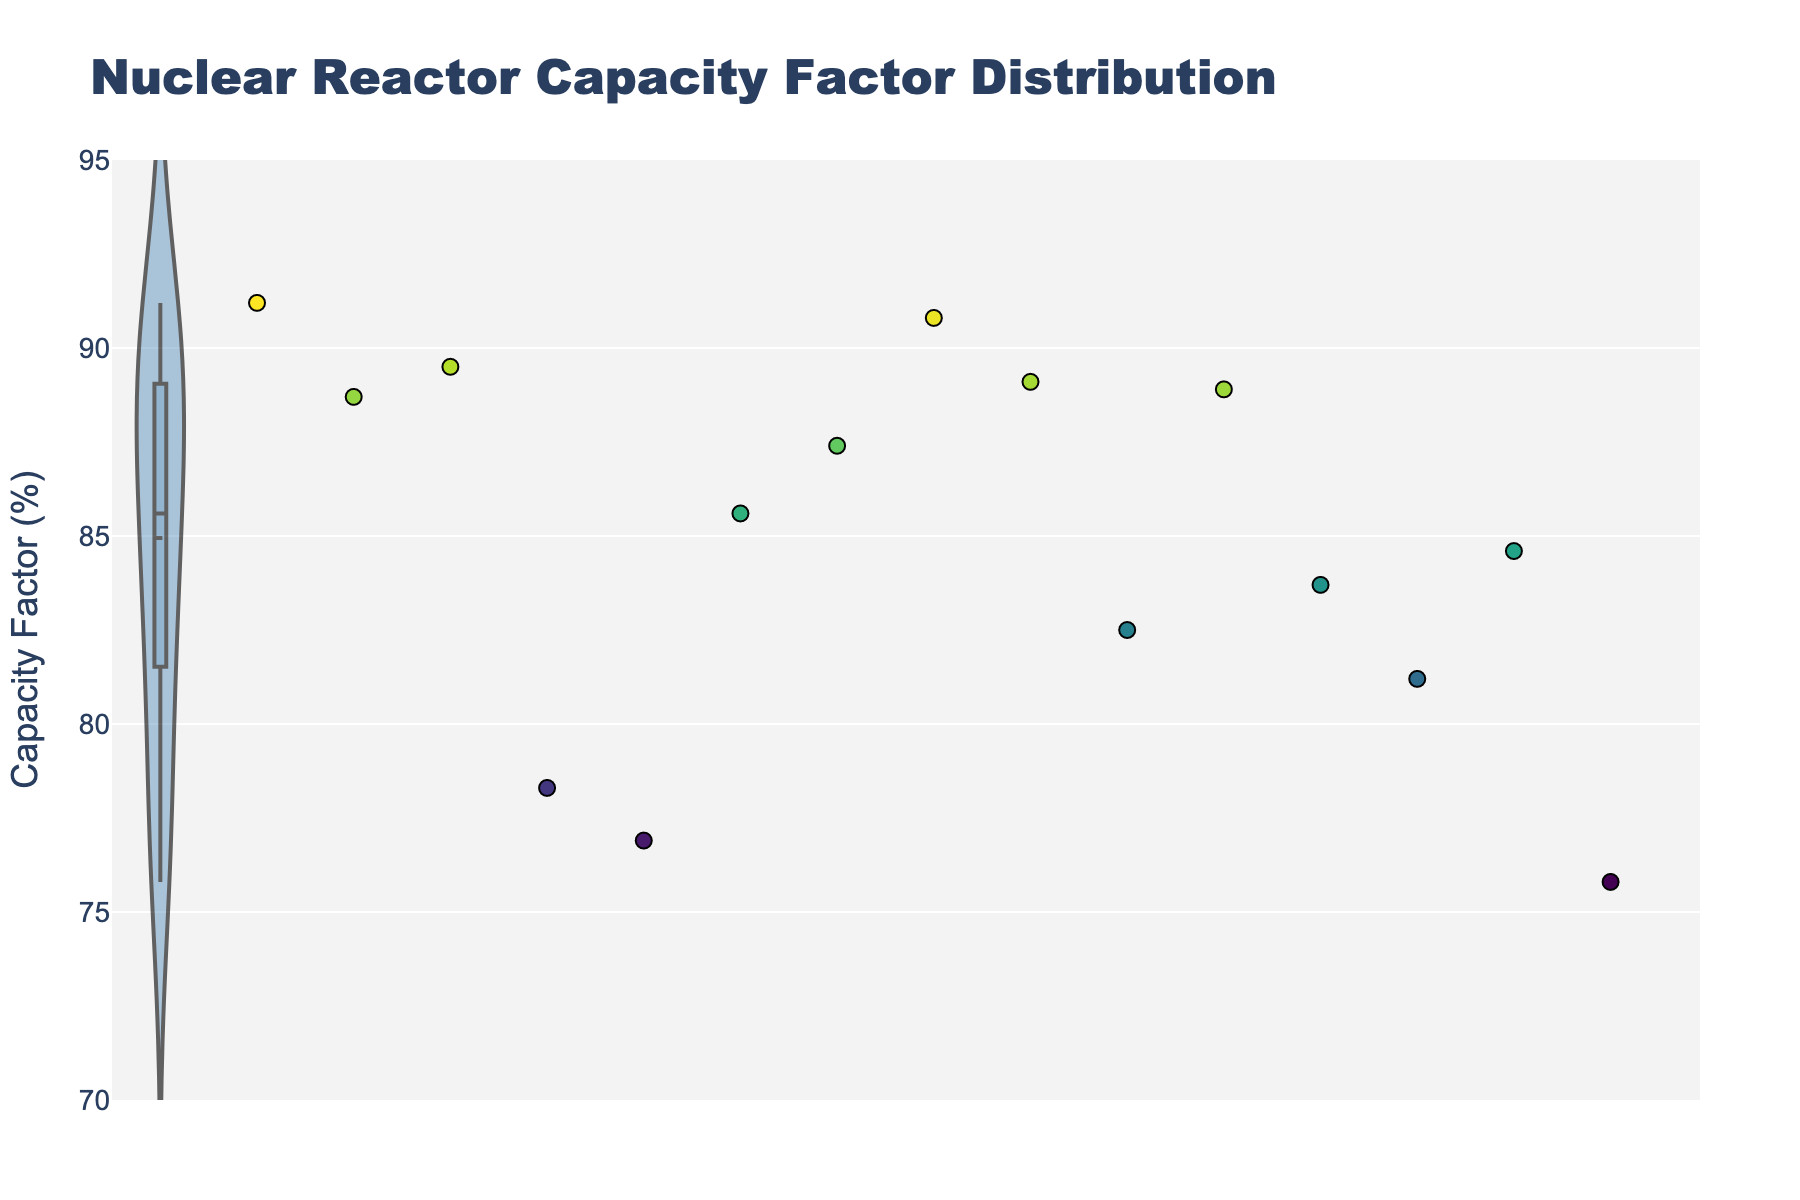What is the title of the plot? The title of the plot is displayed prominently at the top and clearly states the subject of the plot.
Answer: Nuclear Reactor Capacity Factor Distribution What is the range of the y-axis? The y-axis range can be determined by looking at the lowest and highest values marked on the y-axis.
Answer: 70 to 95 How many reactor types are represented in the plot? Each data point in the scatter plot represents a reactor type. Count the number of unique points.
Answer: 15 Which reactor type has the lowest capacity factor? Hover over the scatter points to see the capacity factors of each reactor type. Identify the one with the lowest value.
Answer: Magnox What is the average capacity factor of all reactor types? Sum up all the capacity factors and divide by the total number of reactor types. \(\frac{(91.2 + 88.7 + 89.5 + 78.3 + 76.9 + 85.6 + 87.4 + 90.8 + 89.1 + 82.5 + 88.9 + 83.7 + 81.2 + 84.6 + 75.8)}{15}\)
Answer: 84.7 What is the difference between the highest and lowest capacity factors? Identify the highest and lowest capacity factors on the plot and subtract the lowest from the highest (91.2 - 75.8).
Answer: 15.4 Which reactor type has a capacity factor closest to 90%? Hover over the scatter points to see the capacity factors. Identify the data point with a value close to 90%.
Answer: AP1000 How many reactor types have a capacity factor above 85%? Count the scatter points that have capacity factors greater than 85 by hovering over each of them.
Answer: 8 What's the capacity factor of Pressurized Water Reactor compared to Boiling Water Reactor? Look at the capacity factor values for both reactor types and compare them (91.2 for Pressurized Water Reactor and 88.7 for Boiling Water Reactor).
Answer: Pressurized Water Reactor is higher What is the median capacity factor? Arrange all capacity factors in numerical order and find the middle value. If the number is even, average the two middle numbers. Here, the values are: 75.8, 76.9, 78.3, 81.2, 82.5, 83.7, 84.6, 85.6, 87.4, 88.7, 88.9, 89.1, 89.5, 90.8, 91.2. The median is 85.6.
Answer: 85.6 